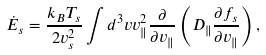Convert formula to latex. <formula><loc_0><loc_0><loc_500><loc_500>\dot { E } _ { s } = \frac { k _ { B } T _ { s } } { 2 v _ { s } ^ { 2 } } \int d ^ { 3 } v v _ { \| } ^ { 2 } \frac { \partial } { \partial v _ { \| } } \left ( D _ { \| } \frac { \partial f _ { s } } { \partial v _ { \| } } \right ) ,</formula> 